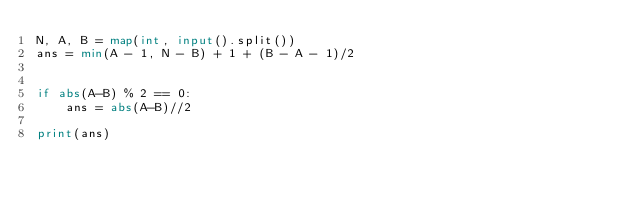<code> <loc_0><loc_0><loc_500><loc_500><_Python_>N, A, B = map(int, input().split())
ans = min(A - 1, N - B) + 1 + (B - A - 1)/2


if abs(A-B) % 2 == 0:
    ans = abs(A-B)//2

print(ans)</code> 